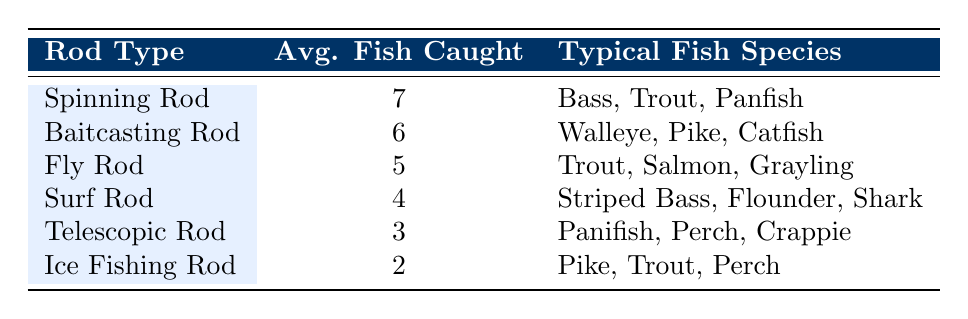What is the average number of fish caught using a Spinning Rod? From the table, the average number of fish caught with a Spinning Rod is clearly listed as 7.
Answer: 7 Which rod type has the highest average fish caught per trip? The table indicates that the Spinning Rod has the highest average at 7 fish, compared to all other rod types listed.
Answer: Spinning Rod Is it true that the Ice Fishing Rod is used to catch more fish on average than the Telescopic Rod? The average for the Ice Fishing Rod is 2, while the Telescopic Rod has an average of 3. Therefore, this statement is false.
Answer: No What is the total average number of fish caught per trip for both the Baitcasting Rod and the Surf Rod? The Baitcasting Rod averages 6 fish caught per trip and the Surf Rod averages 4. Adding them together gives 6 + 4 = 10.
Answer: 10 Which rod type is used primarily for catching Walleye, and what is its average? The Baitcasting Rod is used for Walleye, with an average of 6 fish caught per trip, as shown in the table.
Answer: Baitcasting Rod, 6 What is the difference in average fish caught between the Fly Rod and the Surf Rod? The Fly Rod averages 5 fish while the Surf Rod averages 4 fish. The difference is 5 - 4 = 1.
Answer: 1 Does the average fish caught decrease consistently from Spinning Rod to Ice Fishing Rod? If we assess the averages, Spinning Rod (7), Baitcasting Rod (6), Fly Rod (5), Surf Rod (4), Telescopic Rod (3), and Ice Fishing Rod (2) show a consistent decrease. Hence, the statement is true.
Answer: Yes If a fisherman uses a Telescopic Rod, what is the range of fish species they might catch? The Telescopic Rod is associated with Panfish, Perch, and Crappie, as indicated in the Typical Fish Species column for that rod type in the table.
Answer: Panfish, Perch, Crappie 